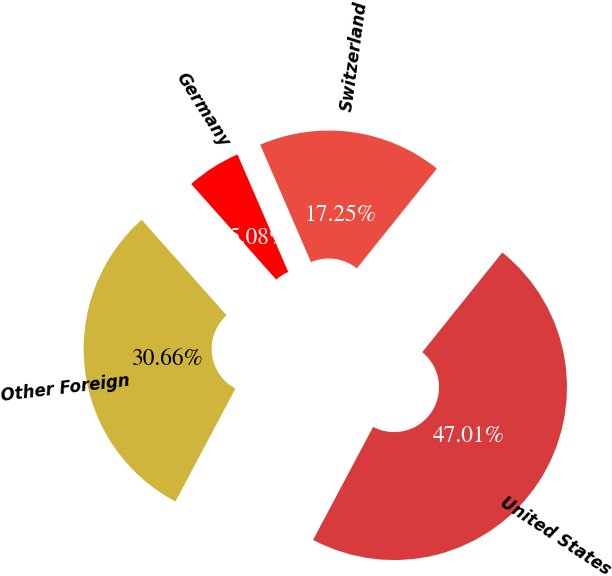Convert chart to OTSL. <chart><loc_0><loc_0><loc_500><loc_500><pie_chart><fcel>United States<fcel>Switzerland<fcel>Germany<fcel>Other Foreign<nl><fcel>47.01%<fcel>17.25%<fcel>5.08%<fcel>30.66%<nl></chart> 